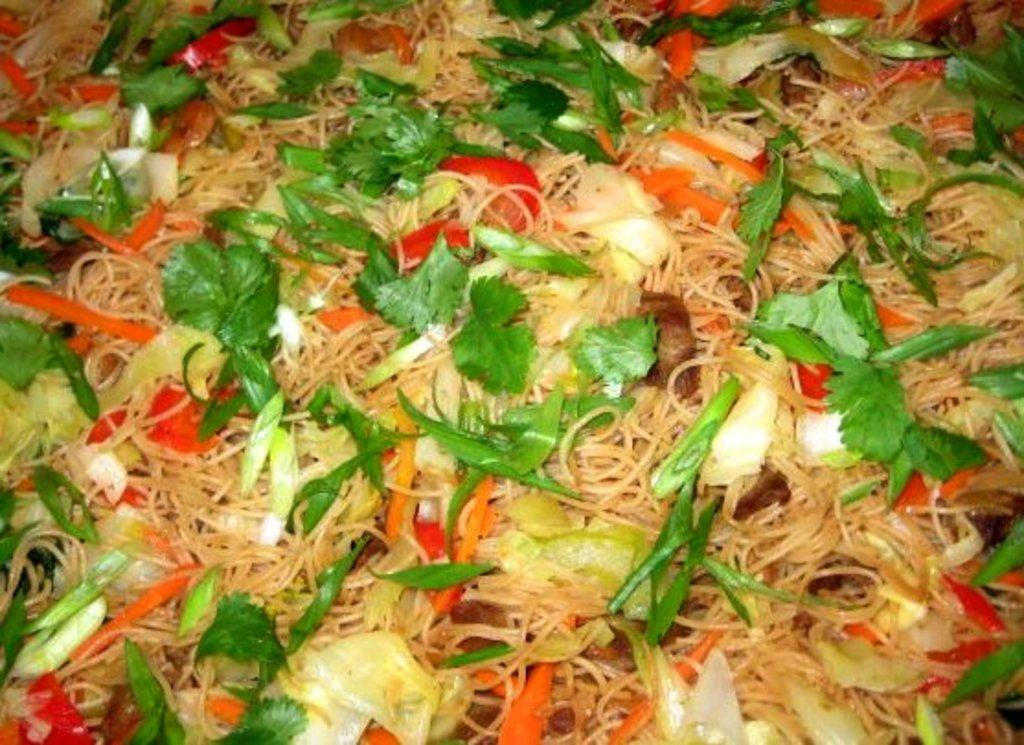What type of food contains noodles in the image? There is food containing noodles in the image. What vegetables can be seen in the food? There are pieces of carrot, cabbage, and beans in the food. What herb is present in the food? There are coriander leaves in the food. How many men are sleeping on the noodles in the image? There are no men or sleeping figures present in the image; it features food containing noodles with various vegetables and herbs. 